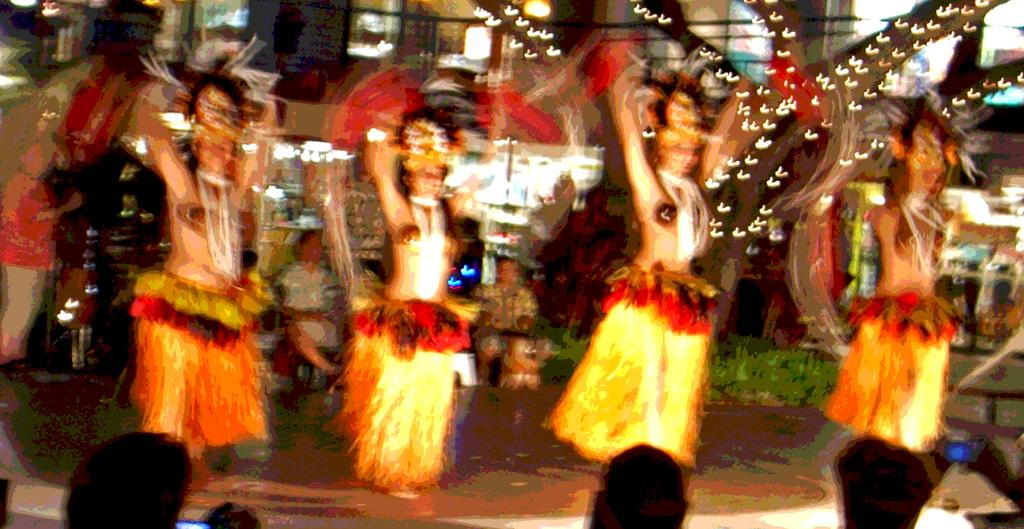Who or what is present in the image? There are people in the image. What natural element can be seen in the image? There is a tree in the image. Are there any artificial light sources in the image? Yes, decorative lights are visible in the image. What type of structure is present in the image? There is a building in the image. What type of guitar can be seen hanging from the tree in the image? There is no guitar present in the image; it only features people, a tree, decorative lights, and a building. How many robins are perched on the branches of the tree in the image? There are no robins present in the image; only a tree is visible. 